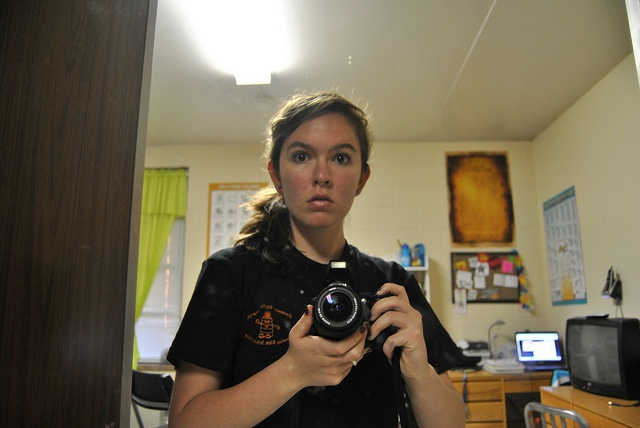Describe the objects in this image and their specific colors. I can see people in black, gray, maroon, and tan tones, tv in black and gray tones, chair in black, darkgray, and gray tones, laptop in black, white, navy, and blue tones, and chair in black, gray, and olive tones in this image. 